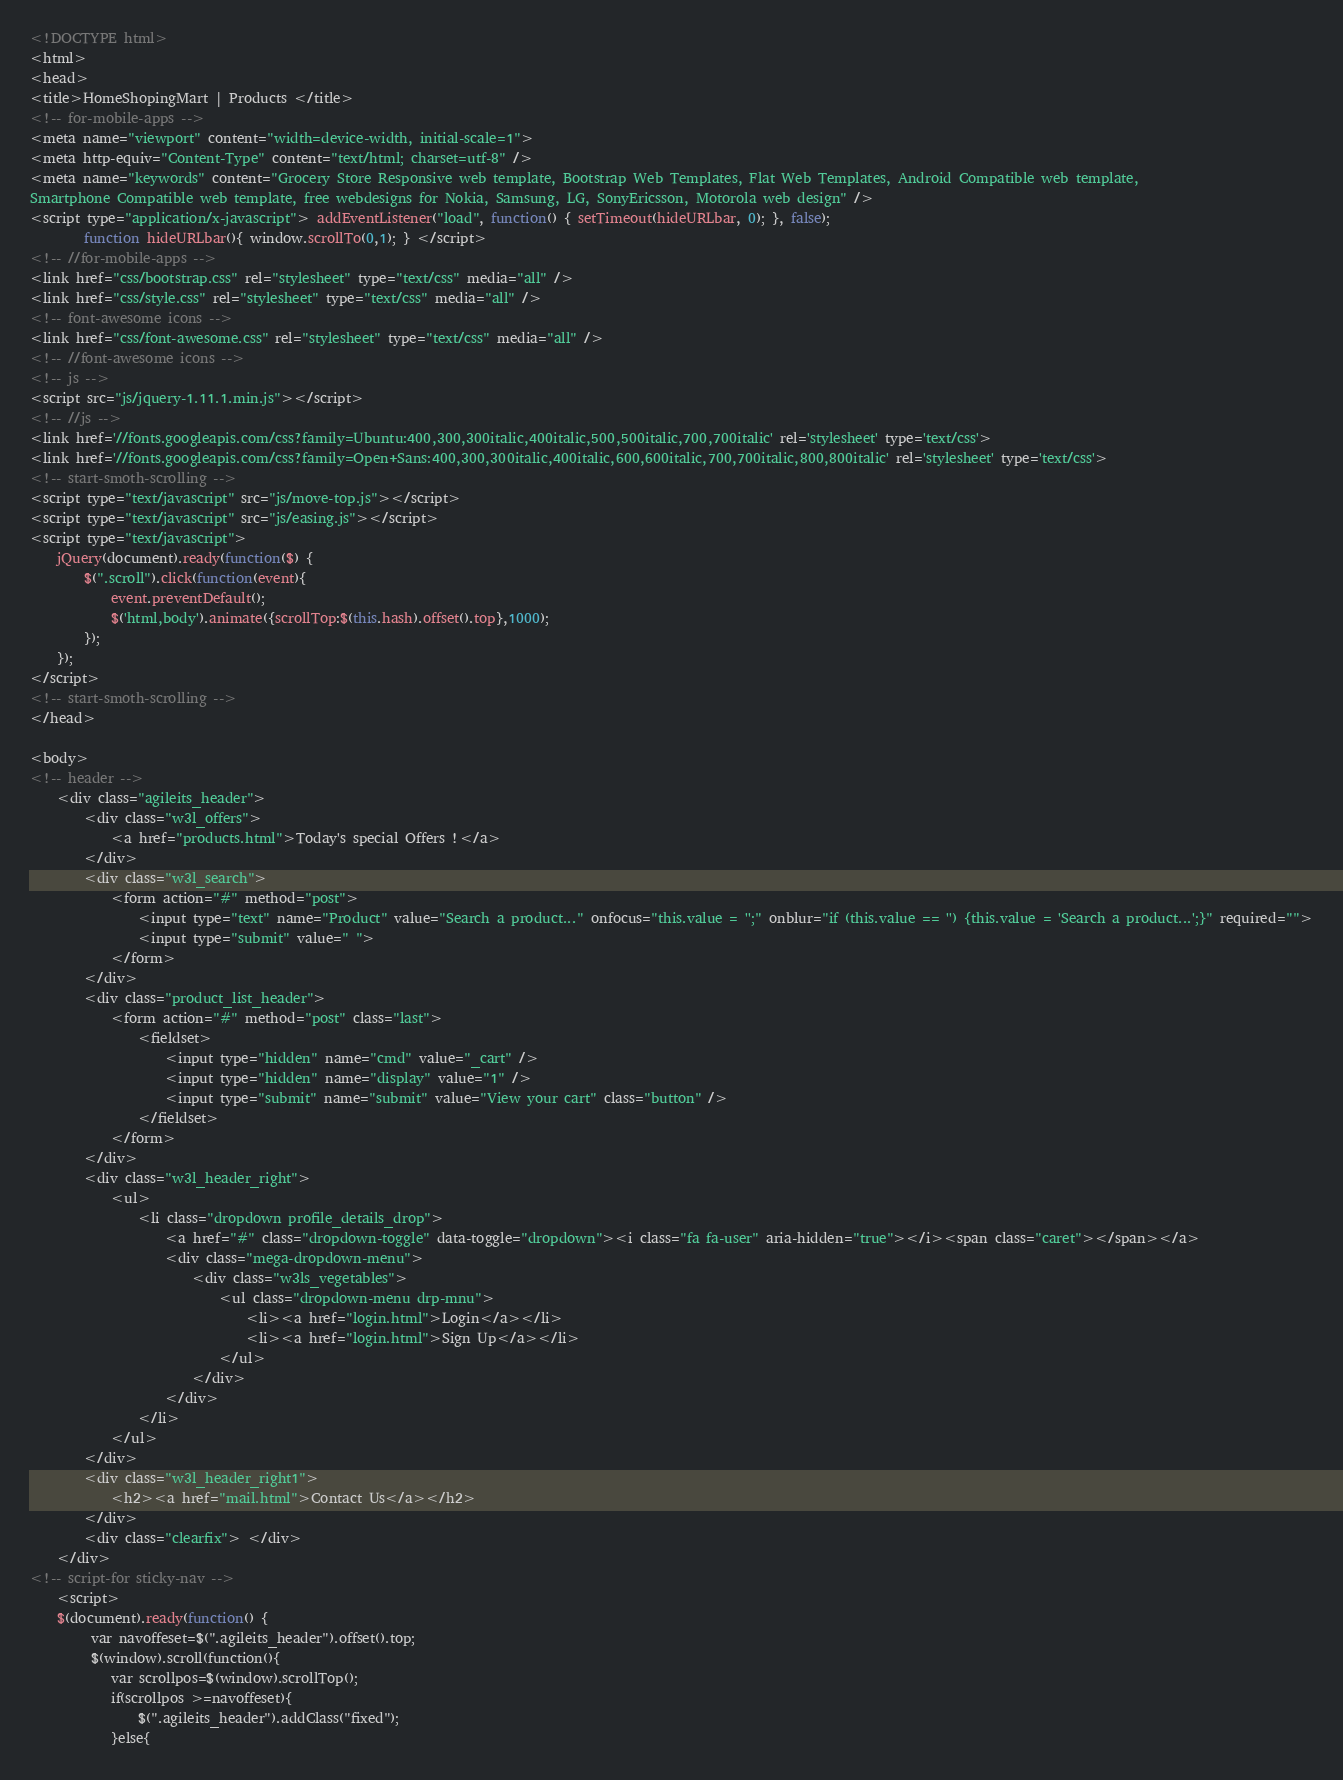<code> <loc_0><loc_0><loc_500><loc_500><_HTML_><!DOCTYPE html>
<html>
<head>
<title>HomeShopingMart | Products </title>
<!-- for-mobile-apps -->
<meta name="viewport" content="width=device-width, initial-scale=1">
<meta http-equiv="Content-Type" content="text/html; charset=utf-8" />
<meta name="keywords" content="Grocery Store Responsive web template, Bootstrap Web Templates, Flat Web Templates, Android Compatible web template, 
Smartphone Compatible web template, free webdesigns for Nokia, Samsung, LG, SonyEricsson, Motorola web design" />
<script type="application/x-javascript"> addEventListener("load", function() { setTimeout(hideURLbar, 0); }, false);
		function hideURLbar(){ window.scrollTo(0,1); } </script>
<!-- //for-mobile-apps -->
<link href="css/bootstrap.css" rel="stylesheet" type="text/css" media="all" />
<link href="css/style.css" rel="stylesheet" type="text/css" media="all" />
<!-- font-awesome icons -->
<link href="css/font-awesome.css" rel="stylesheet" type="text/css" media="all" /> 
<!-- //font-awesome icons -->
<!-- js -->
<script src="js/jquery-1.11.1.min.js"></script>
<!-- //js -->
<link href='//fonts.googleapis.com/css?family=Ubuntu:400,300,300italic,400italic,500,500italic,700,700italic' rel='stylesheet' type='text/css'>
<link href='//fonts.googleapis.com/css?family=Open+Sans:400,300,300italic,400italic,600,600italic,700,700italic,800,800italic' rel='stylesheet' type='text/css'>
<!-- start-smoth-scrolling -->
<script type="text/javascript" src="js/move-top.js"></script>
<script type="text/javascript" src="js/easing.js"></script>
<script type="text/javascript">
	jQuery(document).ready(function($) {
		$(".scroll").click(function(event){		
			event.preventDefault();
			$('html,body').animate({scrollTop:$(this.hash).offset().top},1000);
		});
	});
</script>
<!-- start-smoth-scrolling -->
</head>
	
<body>
<!-- header -->
	<div class="agileits_header">
		<div class="w3l_offers">
			<a href="products.html">Today's special Offers !</a>
		</div>
		<div class="w3l_search">
			<form action="#" method="post">
				<input type="text" name="Product" value="Search a product..." onfocus="this.value = '';" onblur="if (this.value == '') {this.value = 'Search a product...';}" required="">
				<input type="submit" value=" ">
			</form>
		</div>
		<div class="product_list_header">  
			<form action="#" method="post" class="last">
                <fieldset>
                    <input type="hidden" name="cmd" value="_cart" />
                    <input type="hidden" name="display" value="1" />
                    <input type="submit" name="submit" value="View your cart" class="button" />
                </fieldset>
            </form>
		</div>
		<div class="w3l_header_right">
			<ul>
				<li class="dropdown profile_details_drop">
					<a href="#" class="dropdown-toggle" data-toggle="dropdown"><i class="fa fa-user" aria-hidden="true"></i><span class="caret"></span></a>
					<div class="mega-dropdown-menu">
						<div class="w3ls_vegetables">
							<ul class="dropdown-menu drp-mnu">
								<li><a href="login.html">Login</a></li> 
								<li><a href="login.html">Sign Up</a></li>
							</ul>
						</div>                  
					</div>	
				</li>
			</ul>
		</div>
		<div class="w3l_header_right1">
			<h2><a href="mail.html">Contact Us</a></h2>
		</div>
		<div class="clearfix"> </div>
	</div>
<!-- script-for sticky-nav -->
	<script>
	$(document).ready(function() {
		 var navoffeset=$(".agileits_header").offset().top;
		 $(window).scroll(function(){
			var scrollpos=$(window).scrollTop(); 
			if(scrollpos >=navoffeset){
				$(".agileits_header").addClass("fixed");
			}else{</code> 